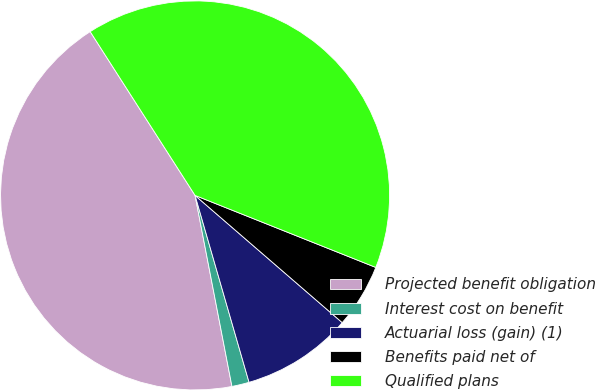Convert chart. <chart><loc_0><loc_0><loc_500><loc_500><pie_chart><fcel>Projected benefit obligation<fcel>Interest cost on benefit<fcel>Actuarial loss (gain) (1)<fcel>Benefits paid net of<fcel>Qualified plans<nl><fcel>43.97%<fcel>1.44%<fcel>9.18%<fcel>5.31%<fcel>40.1%<nl></chart> 